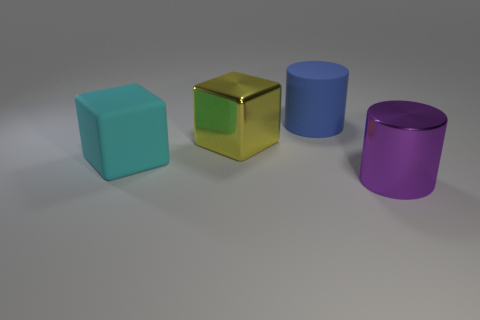Add 3 cyan metallic cubes. How many objects exist? 7 Subtract all big yellow spheres. Subtract all blue things. How many objects are left? 3 Add 4 purple shiny cylinders. How many purple shiny cylinders are left? 5 Add 4 metal blocks. How many metal blocks exist? 5 Subtract 0 blue spheres. How many objects are left? 4 Subtract all cyan cubes. Subtract all yellow cylinders. How many cubes are left? 1 